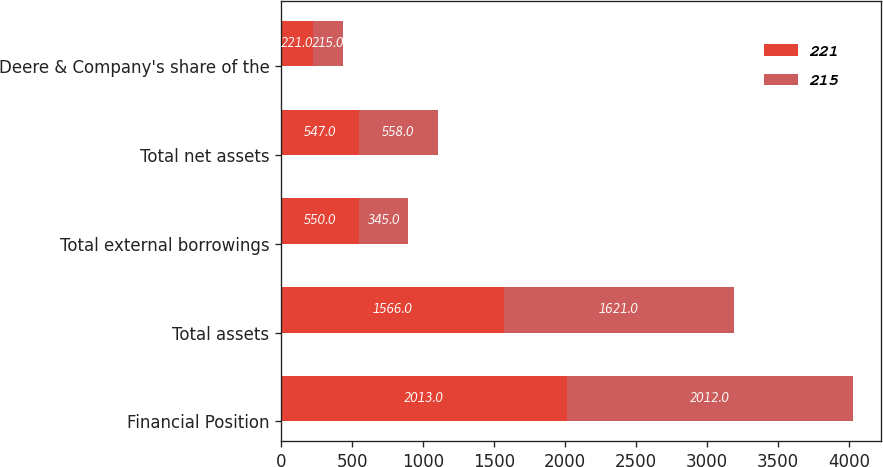<chart> <loc_0><loc_0><loc_500><loc_500><stacked_bar_chart><ecel><fcel>Financial Position<fcel>Total assets<fcel>Total external borrowings<fcel>Total net assets<fcel>Deere & Company's share of the<nl><fcel>221<fcel>2013<fcel>1566<fcel>550<fcel>547<fcel>221<nl><fcel>215<fcel>2012<fcel>1621<fcel>345<fcel>558<fcel>215<nl></chart> 